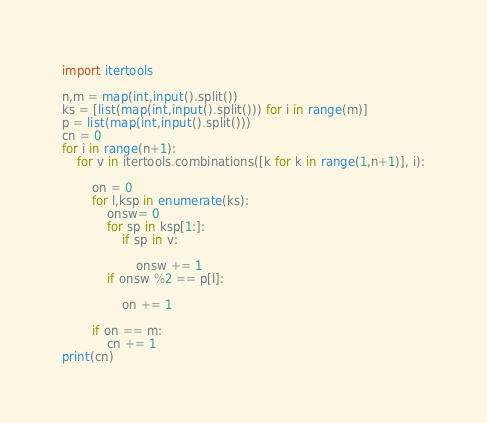Convert code to text. <code><loc_0><loc_0><loc_500><loc_500><_Python_>import itertools

n,m = map(int,input().split())
ks = [list(map(int,input().split())) for i in range(m)]
p = list(map(int,input().split()))
cn = 0
for i in range(n+1):
    for v in itertools.combinations([k for k in range(1,n+1)], i):
        
        on = 0
        for l,ksp in enumerate(ks):
            onsw= 0
            for sp in ksp[1:]:
                if sp in v:
                    
                    onsw += 1
            if onsw %2 == p[l]:
                
                on += 1
        
        if on == m:
            cn += 1
print(cn)</code> 